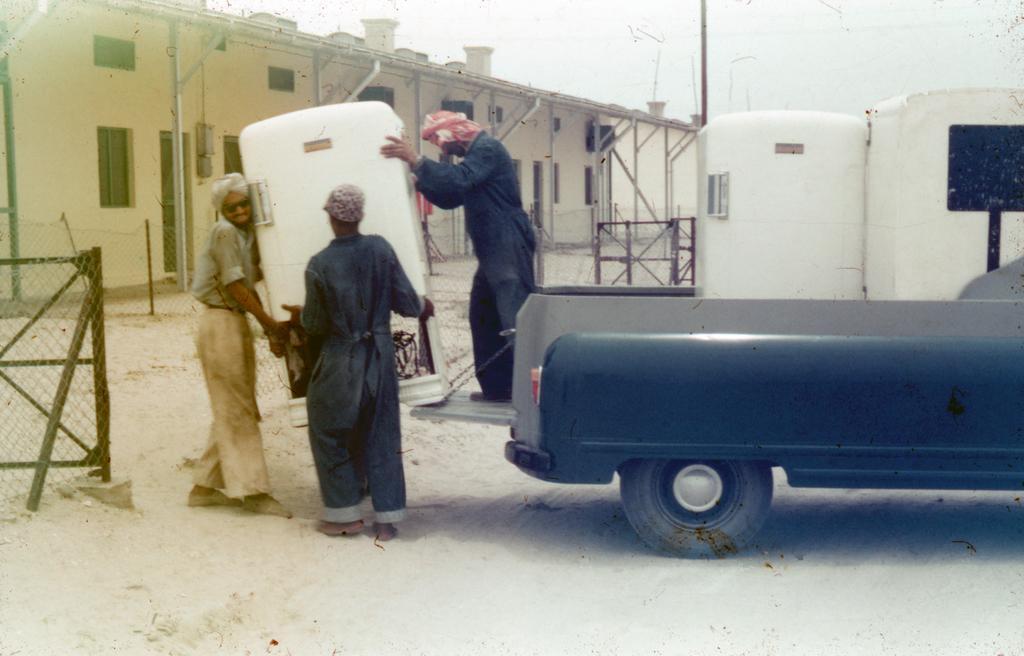Can you describe this image briefly? In this image we can see a vehicle. There are three persons holding a white color object. In the background of the image there is a house with doors and windows. There is fencing. At the bottom of the image there is sand. 